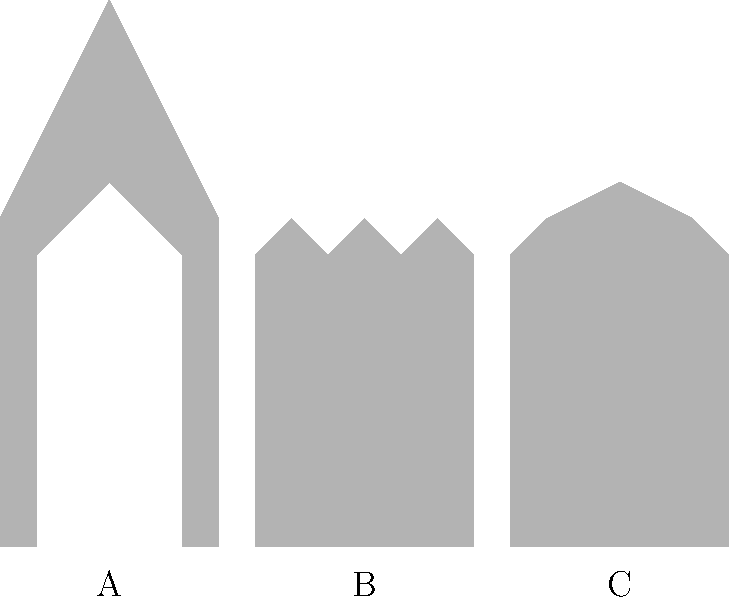As a historian with a keen interest in architectural evolution, analyze the silhouettes of the three buildings labeled A, B, and C. Which architectural style does building B represent, and how does it differ from the other two styles shown? To answer this question, let's analyze each building silhouette and identify their architectural styles:

1. Building A:
   - Tall, vertical emphasis
   - Pointed arches and spires
   - Complex, intricate design
   This represents Gothic architecture, known for its height and ornate details.

2. Building B:
   - Sturdy, compact appearance
   - Round arches
   - Thick walls (implied by the solid silhouette)
   This represents Romanesque architecture, characterized by its robust and simple design.

3. Building C:
   - Symmetrical design
   - Triangular pediment at the top
   - Columns (implied by the regular vertical lines)
   This represents Classical architecture, known for its balance and proportion.

Building B differs from the others in the following ways:
- Compared to Gothic (A), it lacks the vertical emphasis and pointed features.
- Compared to Classical (C), it has a less symmetrical design and lacks the distinctive pediment.
- It features round arches, which are a hallmark of Romanesque style, absent in both Gothic and Classical designs.

The Romanesque style of Building B bridges the gap between Classical Roman architecture and the later Gothic style, representing a transition in architectural history.
Answer: Romanesque; features round arches and sturdy design, contrasting with Gothic's verticality and Classical's symmetry. 